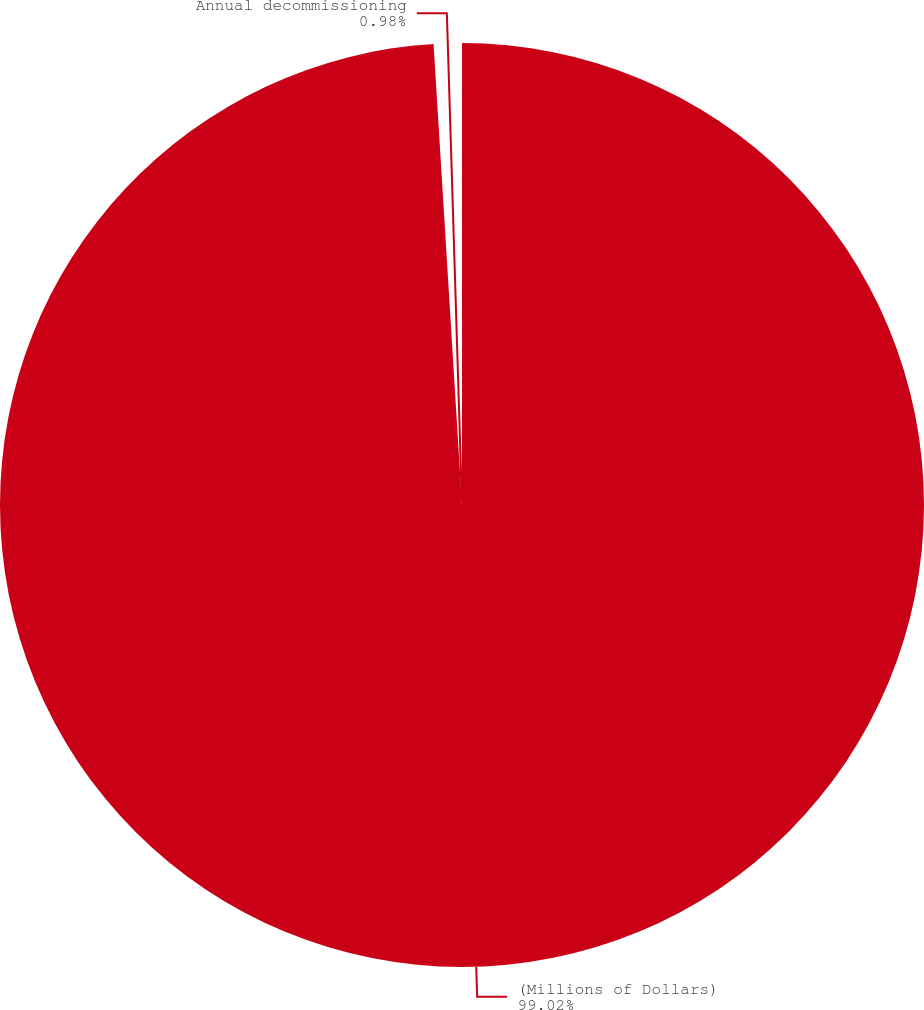Convert chart to OTSL. <chart><loc_0><loc_0><loc_500><loc_500><pie_chart><fcel>(Millions of Dollars)<fcel>Annual decommissioning<nl><fcel>99.02%<fcel>0.98%<nl></chart> 